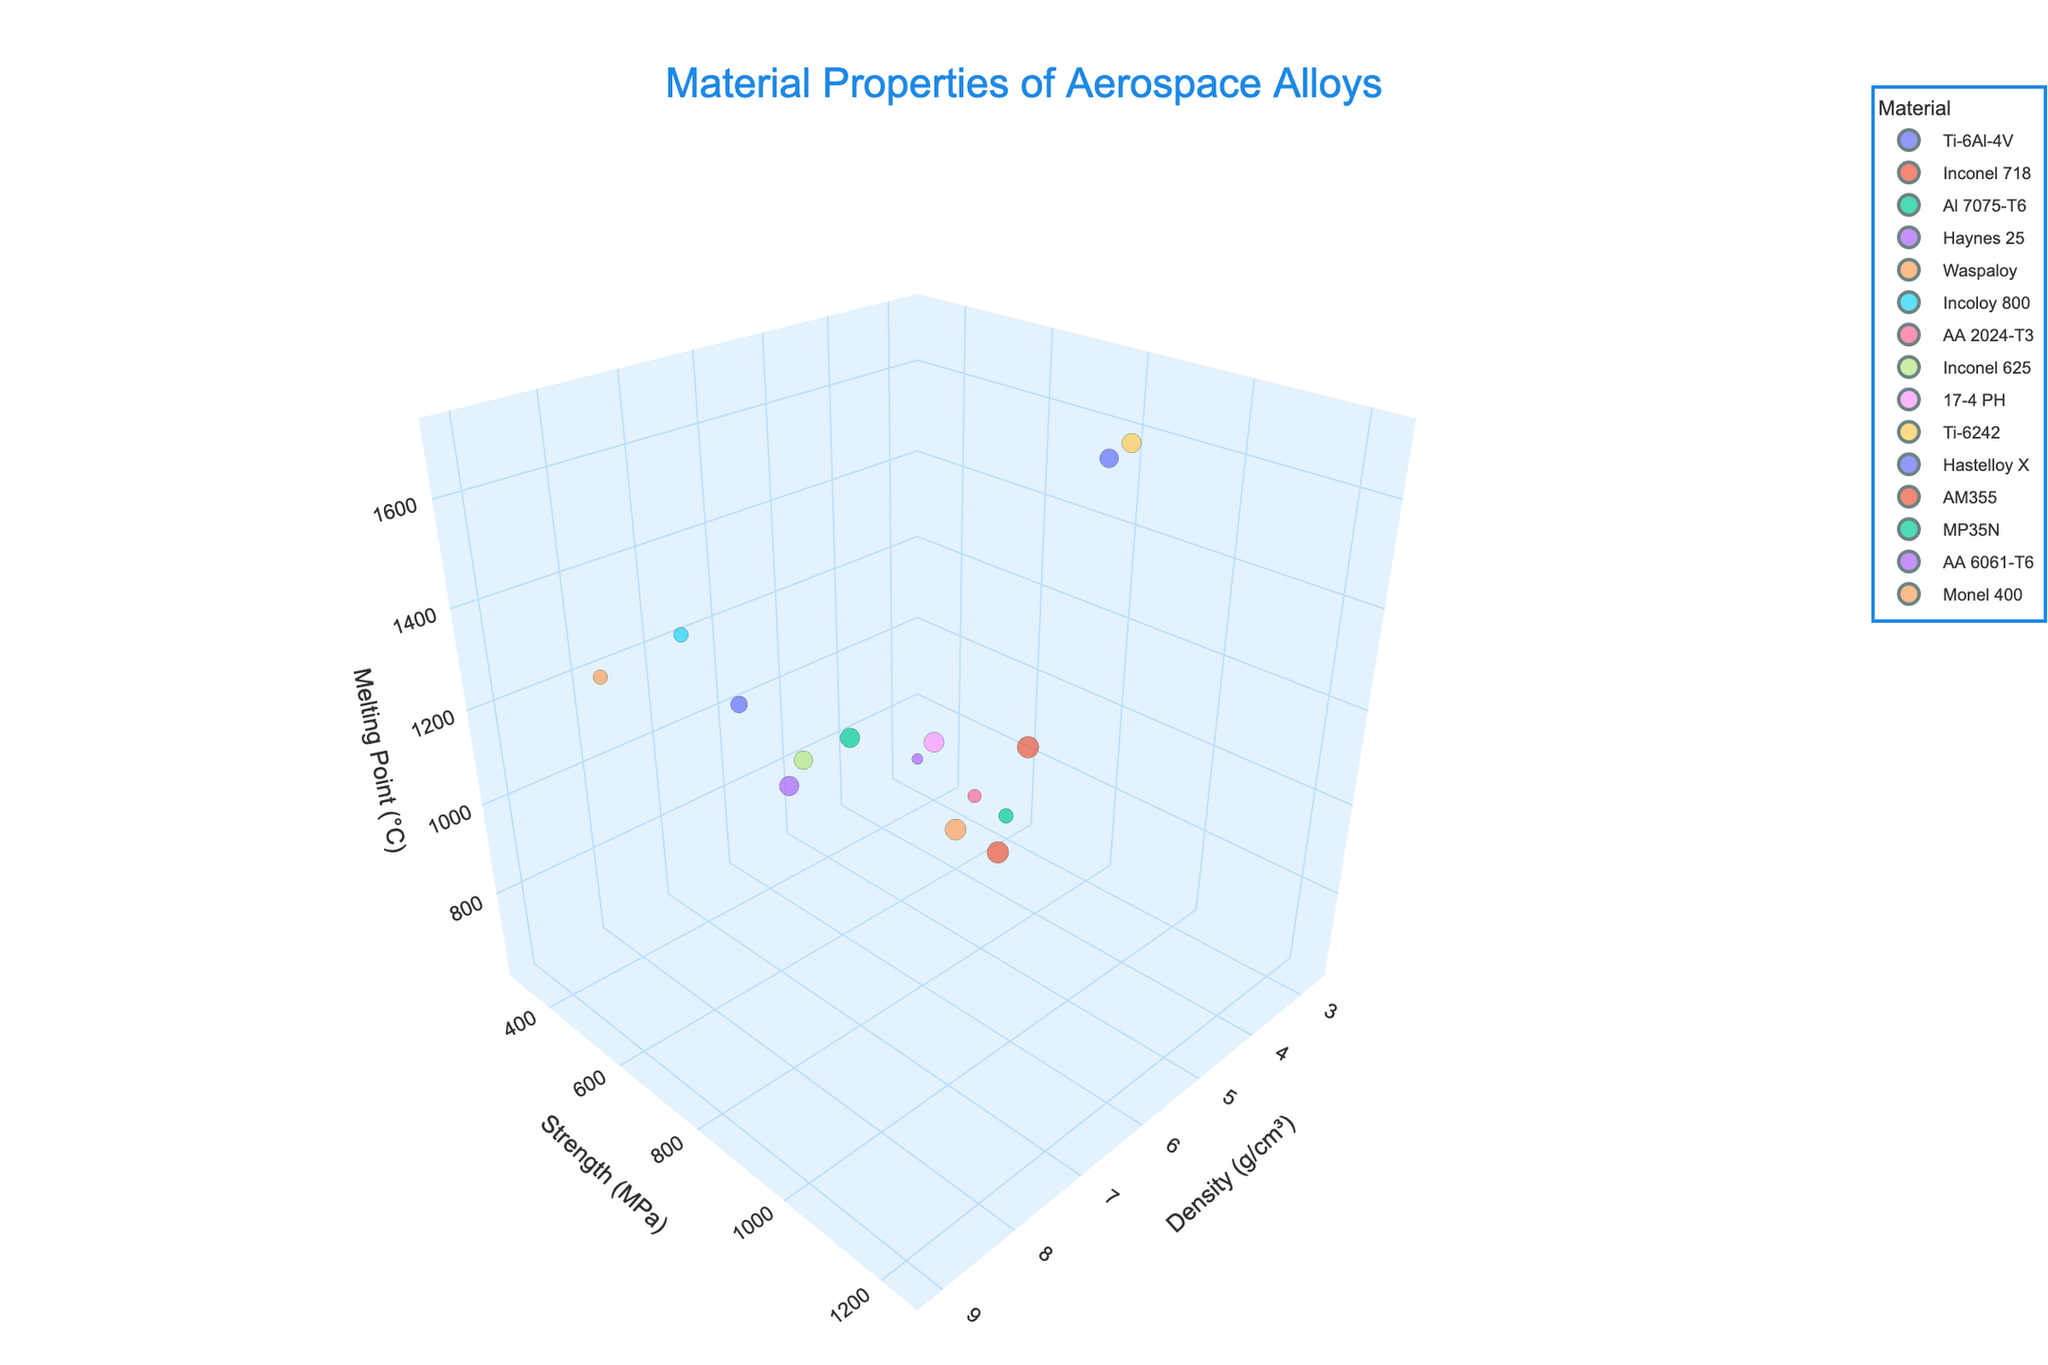What's the title of the figure? The title is displayed at the top of the figure, indicating the content.
Answer: Material Properties of Aerospace Alloys How many materials are plotted in the figure? Each material is represented by a distinct point in the 3D scatter plot. Count the number of different materials listed in the legend.
Answer: 15 Which material has the highest melting point? Look at the z-axis (Melting Point (°C)) and identify the material at the highest position along this axis.
Answer: Ti-6242 What is the density of AA 6061-T6? Find the material AA 6061-T6 in the plot and read its x-axis value (Density (g/cm³)).
Answer: 2.70 g/cm³ Which materials have a density greater than 8 g/cm³? Identify the data points on the x-axis (Density (g/cm³)) that are above 8 and list the corresponding materials.
Answer: Inconel 718, Haynes 25, Waspaloy, Inconel 625, Hastelloy X, Monel 400, AM355, MP35N What is the average strength of all materials? Sum the y-axis values (Strength (MPa)) of all materials and divide by the number of materials.
Answer: (950 + 1240 + 572 + 1020 + 1170 + 580 + 483 + 930 + 1070 + 1000 + 760 + 1240 + 1020 + 310 + 550) / 15 = 873.67 MPa Which material has the smallest strength? Locate the lowest point on the y-axis (Strength (MPa)) and identify the corresponding material.
Answer: AA 6061-T6 Compare the melting points of AA 2024-T3 and Al 7075-T6. Which is higher? Find both materials in the plot and compare their z-axis values (Melting Point (°C)).
Answer: Al 7075-T6 What is the difference in density between Ti-6Al-4V and Inconel 718? Subtract the Density (g/cm³) of Ti-6Al-4V from Inconel 718.
Answer: 8.19 - 4.43 = 3.76 g/cm³ Which material has a higher strength, MP35N or Ti-6242? Compare the y-axis values (Strength (MPa)) of MP35N and Ti-6242.
Answer: MP35N 